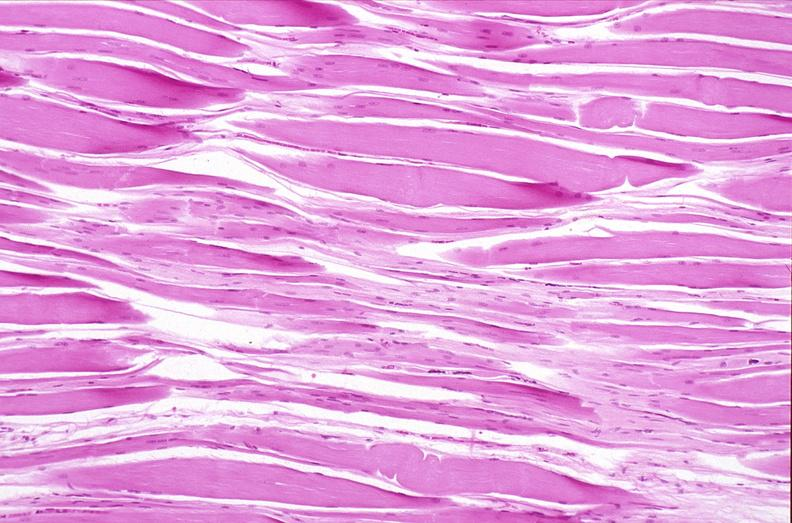does this image show skeletal muscle, atrophy due to immobilization cast?
Answer the question using a single word or phrase. Yes 